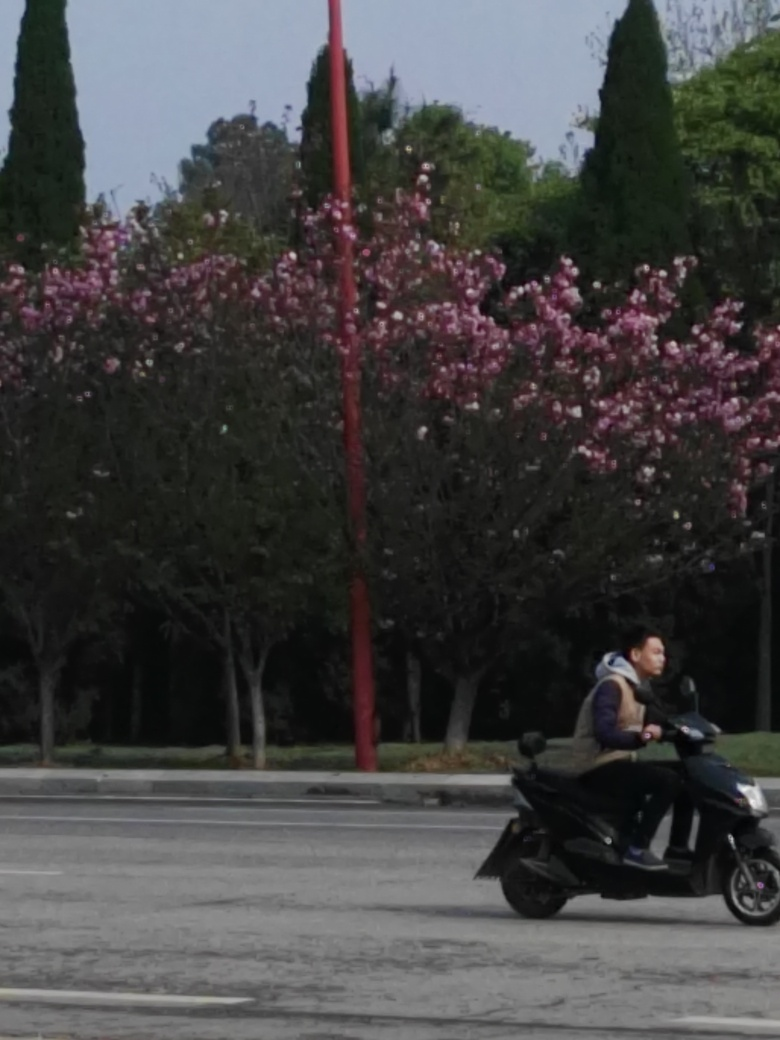What can be said about the sharpness of this image? The sharpness of this image is not very high, which is evident from the slight blurriness and lack of fine detail when observing the textures and edges within the scene. This could be due to various factors such as camera focus, motion blur, or limitations of the camera's sensor. 